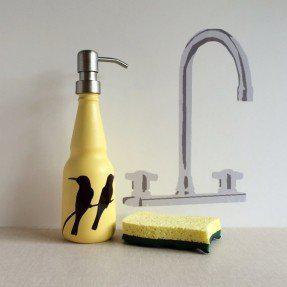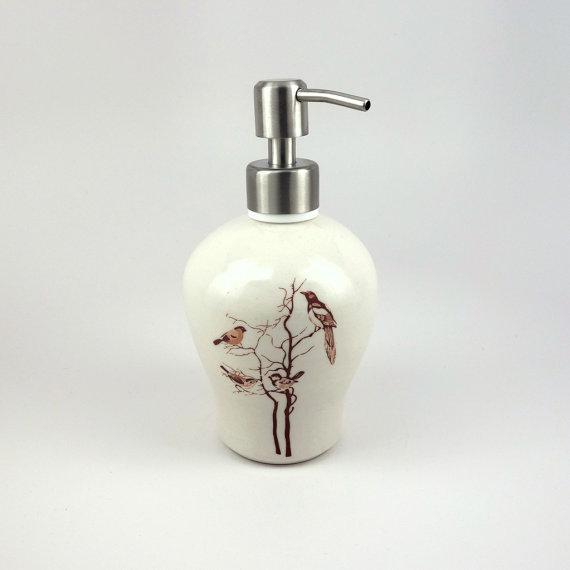The first image is the image on the left, the second image is the image on the right. For the images displayed, is the sentence "At least one soap dispenser has a spout pointing to the left." factually correct? Answer yes or no. No. The first image is the image on the left, the second image is the image on the right. For the images displayed, is the sentence "An image shows one white ceramic-look pump-top dispenser illustrated with a bird likeness." factually correct? Answer yes or no. Yes. 